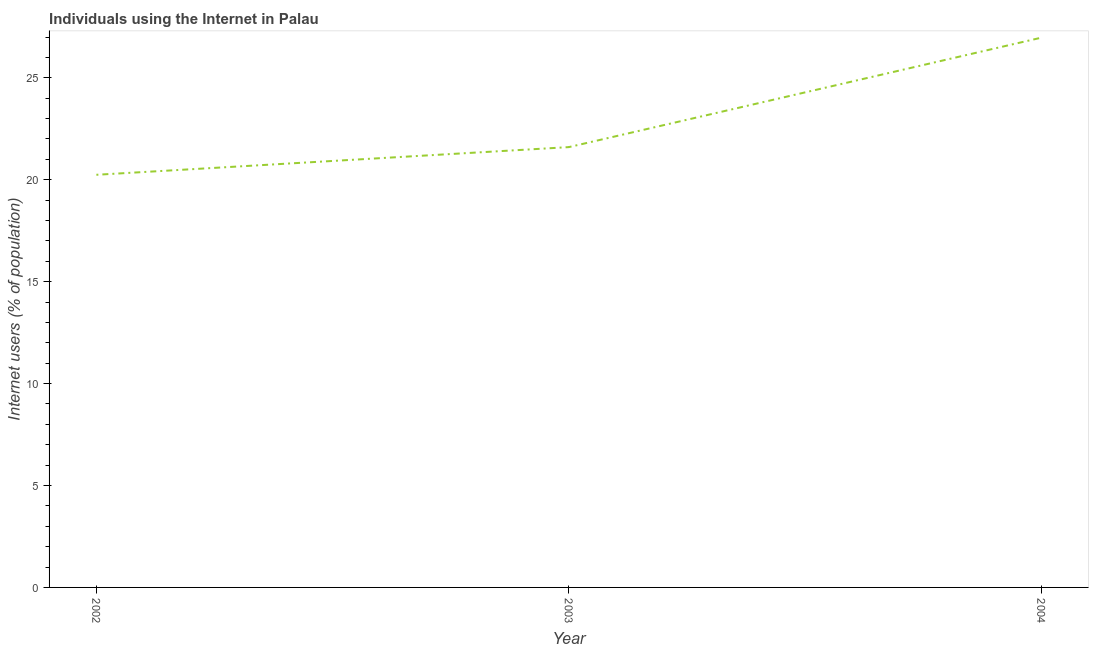What is the number of internet users in 2004?
Offer a very short reply. 26.97. Across all years, what is the maximum number of internet users?
Give a very brief answer. 26.97. Across all years, what is the minimum number of internet users?
Your answer should be compact. 20.24. In which year was the number of internet users minimum?
Make the answer very short. 2002. What is the sum of the number of internet users?
Provide a succinct answer. 68.82. What is the difference between the number of internet users in 2002 and 2003?
Give a very brief answer. -1.36. What is the average number of internet users per year?
Provide a short and direct response. 22.94. What is the median number of internet users?
Your response must be concise. 21.6. In how many years, is the number of internet users greater than 1 %?
Make the answer very short. 3. Do a majority of the years between 2004 and 2003 (inclusive) have number of internet users greater than 24 %?
Make the answer very short. No. What is the ratio of the number of internet users in 2002 to that in 2003?
Your response must be concise. 0.94. Is the difference between the number of internet users in 2002 and 2003 greater than the difference between any two years?
Offer a very short reply. No. What is the difference between the highest and the second highest number of internet users?
Keep it short and to the point. 5.37. Is the sum of the number of internet users in 2002 and 2003 greater than the maximum number of internet users across all years?
Offer a terse response. Yes. What is the difference between the highest and the lowest number of internet users?
Make the answer very short. 6.73. In how many years, is the number of internet users greater than the average number of internet users taken over all years?
Your answer should be compact. 1. Does the number of internet users monotonically increase over the years?
Offer a very short reply. Yes. How many lines are there?
Keep it short and to the point. 1. Does the graph contain any zero values?
Make the answer very short. No. What is the title of the graph?
Keep it short and to the point. Individuals using the Internet in Palau. What is the label or title of the X-axis?
Your answer should be very brief. Year. What is the label or title of the Y-axis?
Provide a short and direct response. Internet users (% of population). What is the Internet users (% of population) of 2002?
Offer a very short reply. 20.24. What is the Internet users (% of population) in 2003?
Provide a succinct answer. 21.6. What is the Internet users (% of population) of 2004?
Your answer should be compact. 26.97. What is the difference between the Internet users (% of population) in 2002 and 2003?
Make the answer very short. -1.36. What is the difference between the Internet users (% of population) in 2002 and 2004?
Make the answer very short. -6.73. What is the difference between the Internet users (% of population) in 2003 and 2004?
Give a very brief answer. -5.37. What is the ratio of the Internet users (% of population) in 2002 to that in 2003?
Your answer should be very brief. 0.94. What is the ratio of the Internet users (% of population) in 2002 to that in 2004?
Ensure brevity in your answer.  0.75. What is the ratio of the Internet users (% of population) in 2003 to that in 2004?
Your answer should be compact. 0.8. 